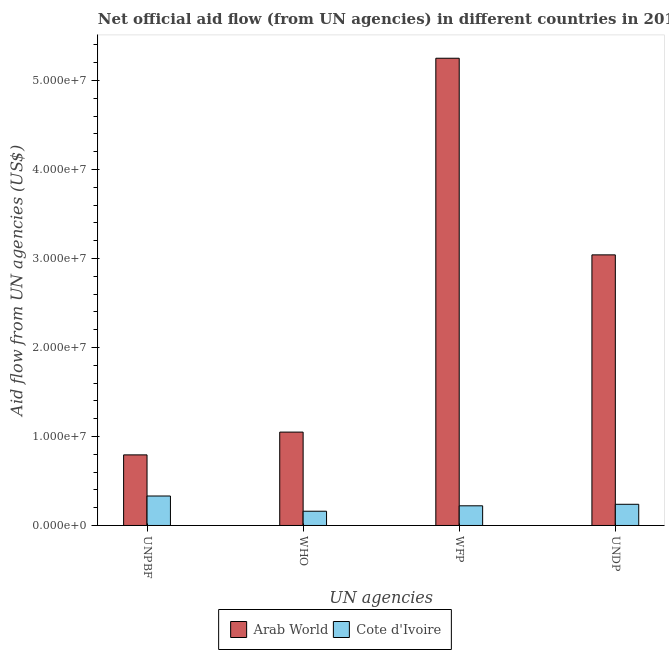How many groups of bars are there?
Provide a succinct answer. 4. Are the number of bars per tick equal to the number of legend labels?
Offer a very short reply. Yes. What is the label of the 3rd group of bars from the left?
Your answer should be compact. WFP. What is the amount of aid given by who in Arab World?
Keep it short and to the point. 1.05e+07. Across all countries, what is the maximum amount of aid given by unpbf?
Provide a succinct answer. 7.93e+06. Across all countries, what is the minimum amount of aid given by who?
Offer a very short reply. 1.60e+06. In which country was the amount of aid given by unpbf maximum?
Make the answer very short. Arab World. In which country was the amount of aid given by unpbf minimum?
Your response must be concise. Cote d'Ivoire. What is the total amount of aid given by undp in the graph?
Offer a very short reply. 3.28e+07. What is the difference between the amount of aid given by who in Arab World and that in Cote d'Ivoire?
Your response must be concise. 8.89e+06. What is the difference between the amount of aid given by undp in Cote d'Ivoire and the amount of aid given by unpbf in Arab World?
Keep it short and to the point. -5.55e+06. What is the average amount of aid given by undp per country?
Keep it short and to the point. 1.64e+07. What is the difference between the amount of aid given by unpbf and amount of aid given by wfp in Arab World?
Make the answer very short. -4.46e+07. In how many countries, is the amount of aid given by undp greater than 46000000 US$?
Keep it short and to the point. 0. What is the ratio of the amount of aid given by undp in Arab World to that in Cote d'Ivoire?
Provide a short and direct response. 12.77. Is the amount of aid given by wfp in Arab World less than that in Cote d'Ivoire?
Offer a very short reply. No. What is the difference between the highest and the second highest amount of aid given by undp?
Offer a terse response. 2.80e+07. What is the difference between the highest and the lowest amount of aid given by wfp?
Your response must be concise. 5.03e+07. What does the 2nd bar from the left in WFP represents?
Ensure brevity in your answer.  Cote d'Ivoire. What does the 1st bar from the right in UNDP represents?
Provide a succinct answer. Cote d'Ivoire. Is it the case that in every country, the sum of the amount of aid given by unpbf and amount of aid given by who is greater than the amount of aid given by wfp?
Keep it short and to the point. No. Are all the bars in the graph horizontal?
Provide a short and direct response. No. Are the values on the major ticks of Y-axis written in scientific E-notation?
Provide a short and direct response. Yes. Does the graph contain any zero values?
Provide a succinct answer. No. Where does the legend appear in the graph?
Offer a very short reply. Bottom center. How many legend labels are there?
Your answer should be very brief. 2. What is the title of the graph?
Your response must be concise. Net official aid flow (from UN agencies) in different countries in 2012. Does "Guinea" appear as one of the legend labels in the graph?
Your answer should be very brief. No. What is the label or title of the X-axis?
Provide a short and direct response. UN agencies. What is the label or title of the Y-axis?
Give a very brief answer. Aid flow from UN agencies (US$). What is the Aid flow from UN agencies (US$) in Arab World in UNPBF?
Offer a terse response. 7.93e+06. What is the Aid flow from UN agencies (US$) of Cote d'Ivoire in UNPBF?
Offer a terse response. 3.31e+06. What is the Aid flow from UN agencies (US$) in Arab World in WHO?
Your response must be concise. 1.05e+07. What is the Aid flow from UN agencies (US$) of Cote d'Ivoire in WHO?
Make the answer very short. 1.60e+06. What is the Aid flow from UN agencies (US$) of Arab World in WFP?
Ensure brevity in your answer.  5.25e+07. What is the Aid flow from UN agencies (US$) of Cote d'Ivoire in WFP?
Make the answer very short. 2.21e+06. What is the Aid flow from UN agencies (US$) of Arab World in UNDP?
Make the answer very short. 3.04e+07. What is the Aid flow from UN agencies (US$) in Cote d'Ivoire in UNDP?
Ensure brevity in your answer.  2.38e+06. Across all UN agencies, what is the maximum Aid flow from UN agencies (US$) of Arab World?
Provide a succinct answer. 5.25e+07. Across all UN agencies, what is the maximum Aid flow from UN agencies (US$) in Cote d'Ivoire?
Provide a succinct answer. 3.31e+06. Across all UN agencies, what is the minimum Aid flow from UN agencies (US$) of Arab World?
Your answer should be very brief. 7.93e+06. Across all UN agencies, what is the minimum Aid flow from UN agencies (US$) of Cote d'Ivoire?
Ensure brevity in your answer.  1.60e+06. What is the total Aid flow from UN agencies (US$) of Arab World in the graph?
Make the answer very short. 1.01e+08. What is the total Aid flow from UN agencies (US$) in Cote d'Ivoire in the graph?
Provide a short and direct response. 9.50e+06. What is the difference between the Aid flow from UN agencies (US$) in Arab World in UNPBF and that in WHO?
Give a very brief answer. -2.56e+06. What is the difference between the Aid flow from UN agencies (US$) in Cote d'Ivoire in UNPBF and that in WHO?
Your answer should be compact. 1.71e+06. What is the difference between the Aid flow from UN agencies (US$) of Arab World in UNPBF and that in WFP?
Provide a succinct answer. -4.46e+07. What is the difference between the Aid flow from UN agencies (US$) in Cote d'Ivoire in UNPBF and that in WFP?
Provide a short and direct response. 1.10e+06. What is the difference between the Aid flow from UN agencies (US$) in Arab World in UNPBF and that in UNDP?
Provide a succinct answer. -2.25e+07. What is the difference between the Aid flow from UN agencies (US$) of Cote d'Ivoire in UNPBF and that in UNDP?
Keep it short and to the point. 9.30e+05. What is the difference between the Aid flow from UN agencies (US$) of Arab World in WHO and that in WFP?
Provide a succinct answer. -4.20e+07. What is the difference between the Aid flow from UN agencies (US$) of Cote d'Ivoire in WHO and that in WFP?
Your answer should be compact. -6.10e+05. What is the difference between the Aid flow from UN agencies (US$) in Arab World in WHO and that in UNDP?
Your answer should be very brief. -1.99e+07. What is the difference between the Aid flow from UN agencies (US$) of Cote d'Ivoire in WHO and that in UNDP?
Offer a terse response. -7.80e+05. What is the difference between the Aid flow from UN agencies (US$) of Arab World in WFP and that in UNDP?
Offer a very short reply. 2.21e+07. What is the difference between the Aid flow from UN agencies (US$) in Arab World in UNPBF and the Aid flow from UN agencies (US$) in Cote d'Ivoire in WHO?
Offer a terse response. 6.33e+06. What is the difference between the Aid flow from UN agencies (US$) in Arab World in UNPBF and the Aid flow from UN agencies (US$) in Cote d'Ivoire in WFP?
Your response must be concise. 5.72e+06. What is the difference between the Aid flow from UN agencies (US$) in Arab World in UNPBF and the Aid flow from UN agencies (US$) in Cote d'Ivoire in UNDP?
Offer a terse response. 5.55e+06. What is the difference between the Aid flow from UN agencies (US$) in Arab World in WHO and the Aid flow from UN agencies (US$) in Cote d'Ivoire in WFP?
Offer a terse response. 8.28e+06. What is the difference between the Aid flow from UN agencies (US$) in Arab World in WHO and the Aid flow from UN agencies (US$) in Cote d'Ivoire in UNDP?
Keep it short and to the point. 8.11e+06. What is the difference between the Aid flow from UN agencies (US$) of Arab World in WFP and the Aid flow from UN agencies (US$) of Cote d'Ivoire in UNDP?
Your response must be concise. 5.01e+07. What is the average Aid flow from UN agencies (US$) in Arab World per UN agencies?
Give a very brief answer. 2.53e+07. What is the average Aid flow from UN agencies (US$) in Cote d'Ivoire per UN agencies?
Offer a terse response. 2.38e+06. What is the difference between the Aid flow from UN agencies (US$) of Arab World and Aid flow from UN agencies (US$) of Cote d'Ivoire in UNPBF?
Make the answer very short. 4.62e+06. What is the difference between the Aid flow from UN agencies (US$) in Arab World and Aid flow from UN agencies (US$) in Cote d'Ivoire in WHO?
Your answer should be compact. 8.89e+06. What is the difference between the Aid flow from UN agencies (US$) of Arab World and Aid flow from UN agencies (US$) of Cote d'Ivoire in WFP?
Provide a succinct answer. 5.03e+07. What is the difference between the Aid flow from UN agencies (US$) in Arab World and Aid flow from UN agencies (US$) in Cote d'Ivoire in UNDP?
Give a very brief answer. 2.80e+07. What is the ratio of the Aid flow from UN agencies (US$) in Arab World in UNPBF to that in WHO?
Make the answer very short. 0.76. What is the ratio of the Aid flow from UN agencies (US$) in Cote d'Ivoire in UNPBF to that in WHO?
Offer a terse response. 2.07. What is the ratio of the Aid flow from UN agencies (US$) of Arab World in UNPBF to that in WFP?
Offer a terse response. 0.15. What is the ratio of the Aid flow from UN agencies (US$) of Cote d'Ivoire in UNPBF to that in WFP?
Your response must be concise. 1.5. What is the ratio of the Aid flow from UN agencies (US$) of Arab World in UNPBF to that in UNDP?
Offer a terse response. 0.26. What is the ratio of the Aid flow from UN agencies (US$) of Cote d'Ivoire in UNPBF to that in UNDP?
Offer a terse response. 1.39. What is the ratio of the Aid flow from UN agencies (US$) of Arab World in WHO to that in WFP?
Provide a short and direct response. 0.2. What is the ratio of the Aid flow from UN agencies (US$) of Cote d'Ivoire in WHO to that in WFP?
Offer a very short reply. 0.72. What is the ratio of the Aid flow from UN agencies (US$) in Arab World in WHO to that in UNDP?
Offer a very short reply. 0.35. What is the ratio of the Aid flow from UN agencies (US$) in Cote d'Ivoire in WHO to that in UNDP?
Give a very brief answer. 0.67. What is the ratio of the Aid flow from UN agencies (US$) of Arab World in WFP to that in UNDP?
Provide a succinct answer. 1.73. What is the ratio of the Aid flow from UN agencies (US$) in Cote d'Ivoire in WFP to that in UNDP?
Keep it short and to the point. 0.93. What is the difference between the highest and the second highest Aid flow from UN agencies (US$) of Arab World?
Your response must be concise. 2.21e+07. What is the difference between the highest and the second highest Aid flow from UN agencies (US$) in Cote d'Ivoire?
Your answer should be compact. 9.30e+05. What is the difference between the highest and the lowest Aid flow from UN agencies (US$) in Arab World?
Offer a very short reply. 4.46e+07. What is the difference between the highest and the lowest Aid flow from UN agencies (US$) in Cote d'Ivoire?
Give a very brief answer. 1.71e+06. 